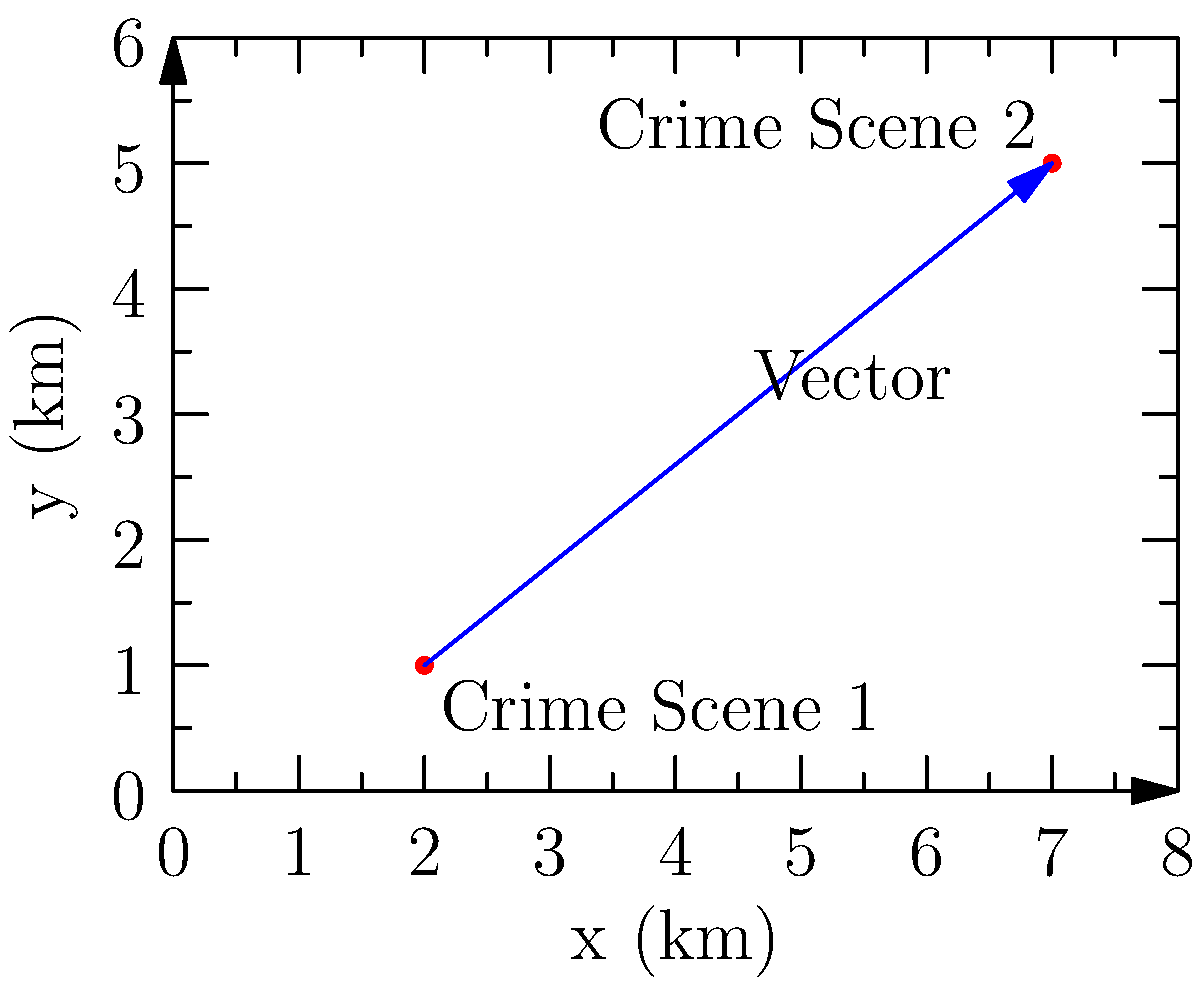As you investigate a case similar to your sister's, you discover two crime scenes that might be connected. Crime Scene 1 is located at coordinates (2 km, 1 km), and Crime Scene 2 is at (7 km, 5 km). Calculate the magnitude of the vector representing the distance between these two crime scenes. How far apart are they? To find the magnitude of the vector between the two crime scenes, we can follow these steps:

1) First, we need to determine the components of the vector:
   x-component: $7 - 2 = 5$ km
   y-component: $5 - 1 = 4$ km

2) The vector can be represented as $\vec{v} = (5, 4)$

3) To calculate the magnitude of this vector, we use the Pythagorean theorem:
   $\text{magnitude} = \sqrt{x^2 + y^2}$

4) Substituting our values:
   $\text{magnitude} = \sqrt{5^2 + 4^2}$

5) Simplify:
   $\text{magnitude} = \sqrt{25 + 16} = \sqrt{41}$

6) Calculate the square root:
   $\text{magnitude} \approx 6.40$ km

Therefore, the distance between the two crime scenes is approximately 6.40 km.
Answer: $\sqrt{41}$ km or approximately 6.40 km 